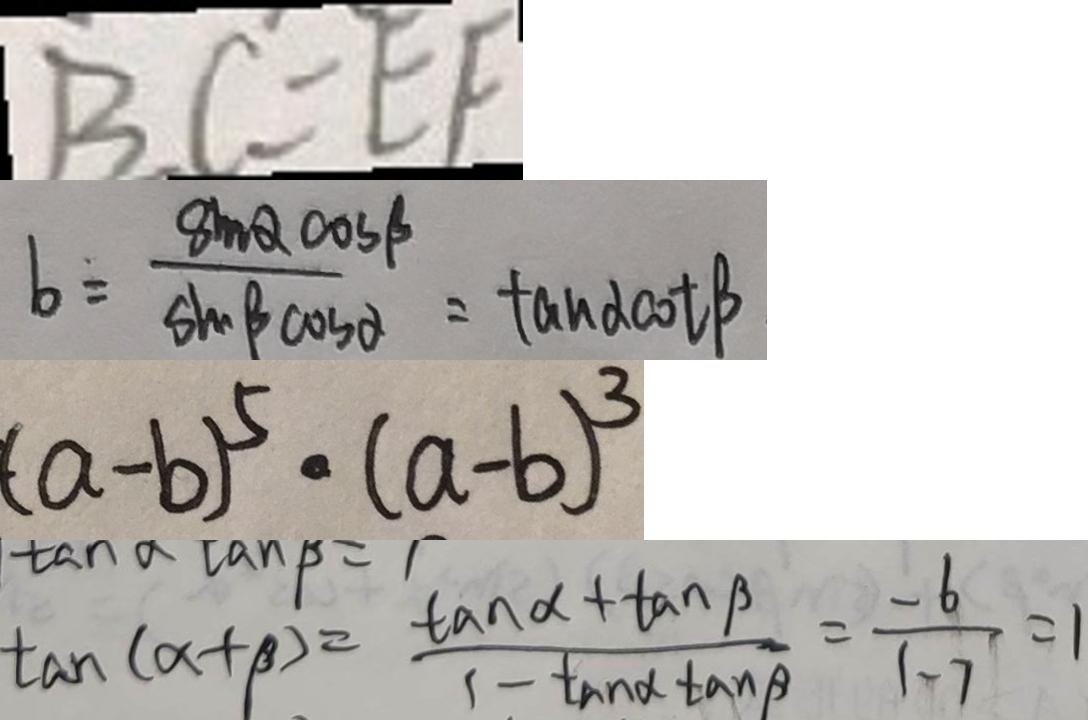Convert formula to latex. <formula><loc_0><loc_0><loc_500><loc_500>B C = E F 
 b = \frac { 8 m Q \cos \beta } { \sin \beta \cos \alpha } = \tan \alpha \cot \beta 
 ( a - b ) ^ { 5 } \cdot ( a - b ) ^ { 3 } 
 \tan ( \alpha + \beta ) = \frac { \tan \alpha + \tan \beta } { 1 - \tan \alpha \tan \beta } = \frac { - 6 } { 1 - 7 } = 1</formula> 